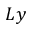Convert formula to latex. <formula><loc_0><loc_0><loc_500><loc_500>L y</formula> 